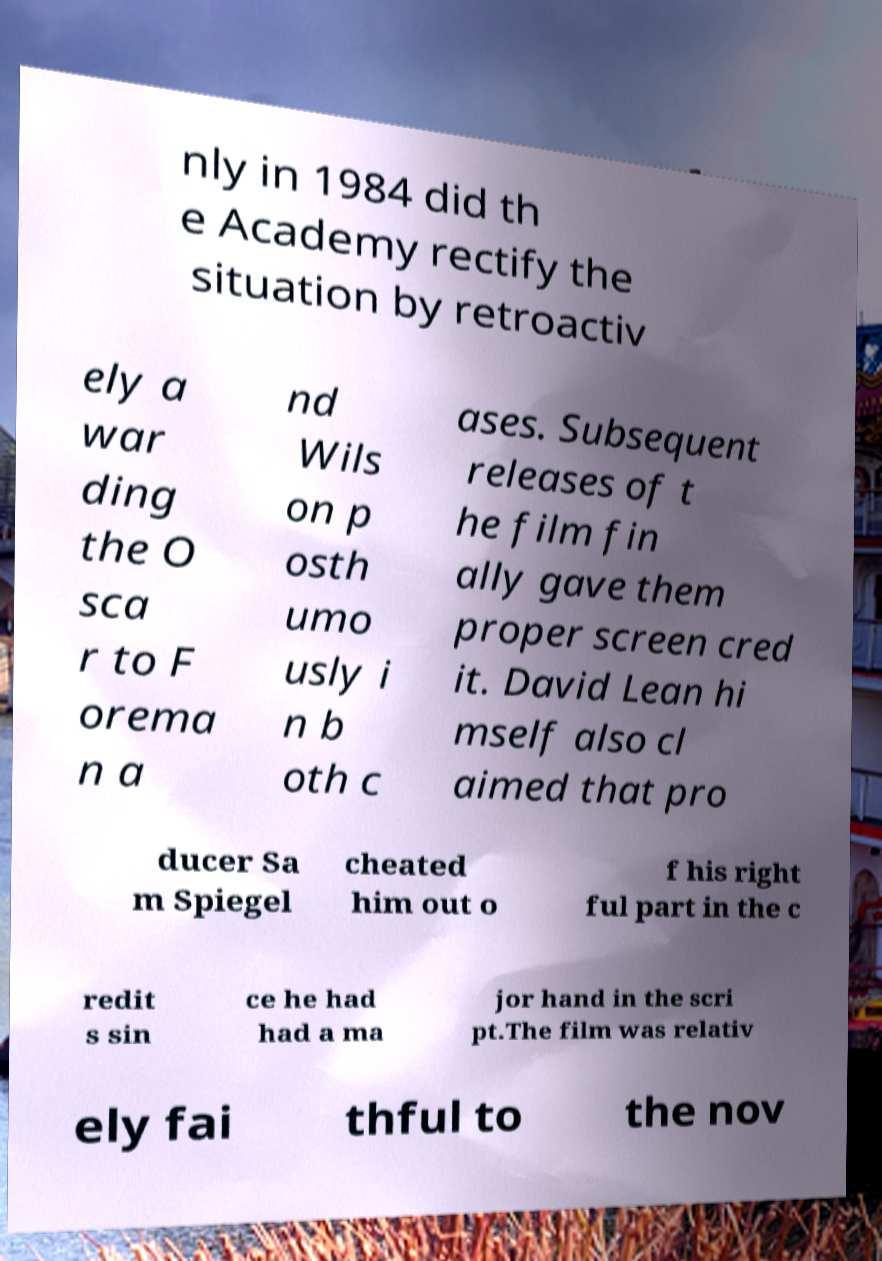Could you assist in decoding the text presented in this image and type it out clearly? nly in 1984 did th e Academy rectify the situation by retroactiv ely a war ding the O sca r to F orema n a nd Wils on p osth umo usly i n b oth c ases. Subsequent releases of t he film fin ally gave them proper screen cred it. David Lean hi mself also cl aimed that pro ducer Sa m Spiegel cheated him out o f his right ful part in the c redit s sin ce he had had a ma jor hand in the scri pt.The film was relativ ely fai thful to the nov 